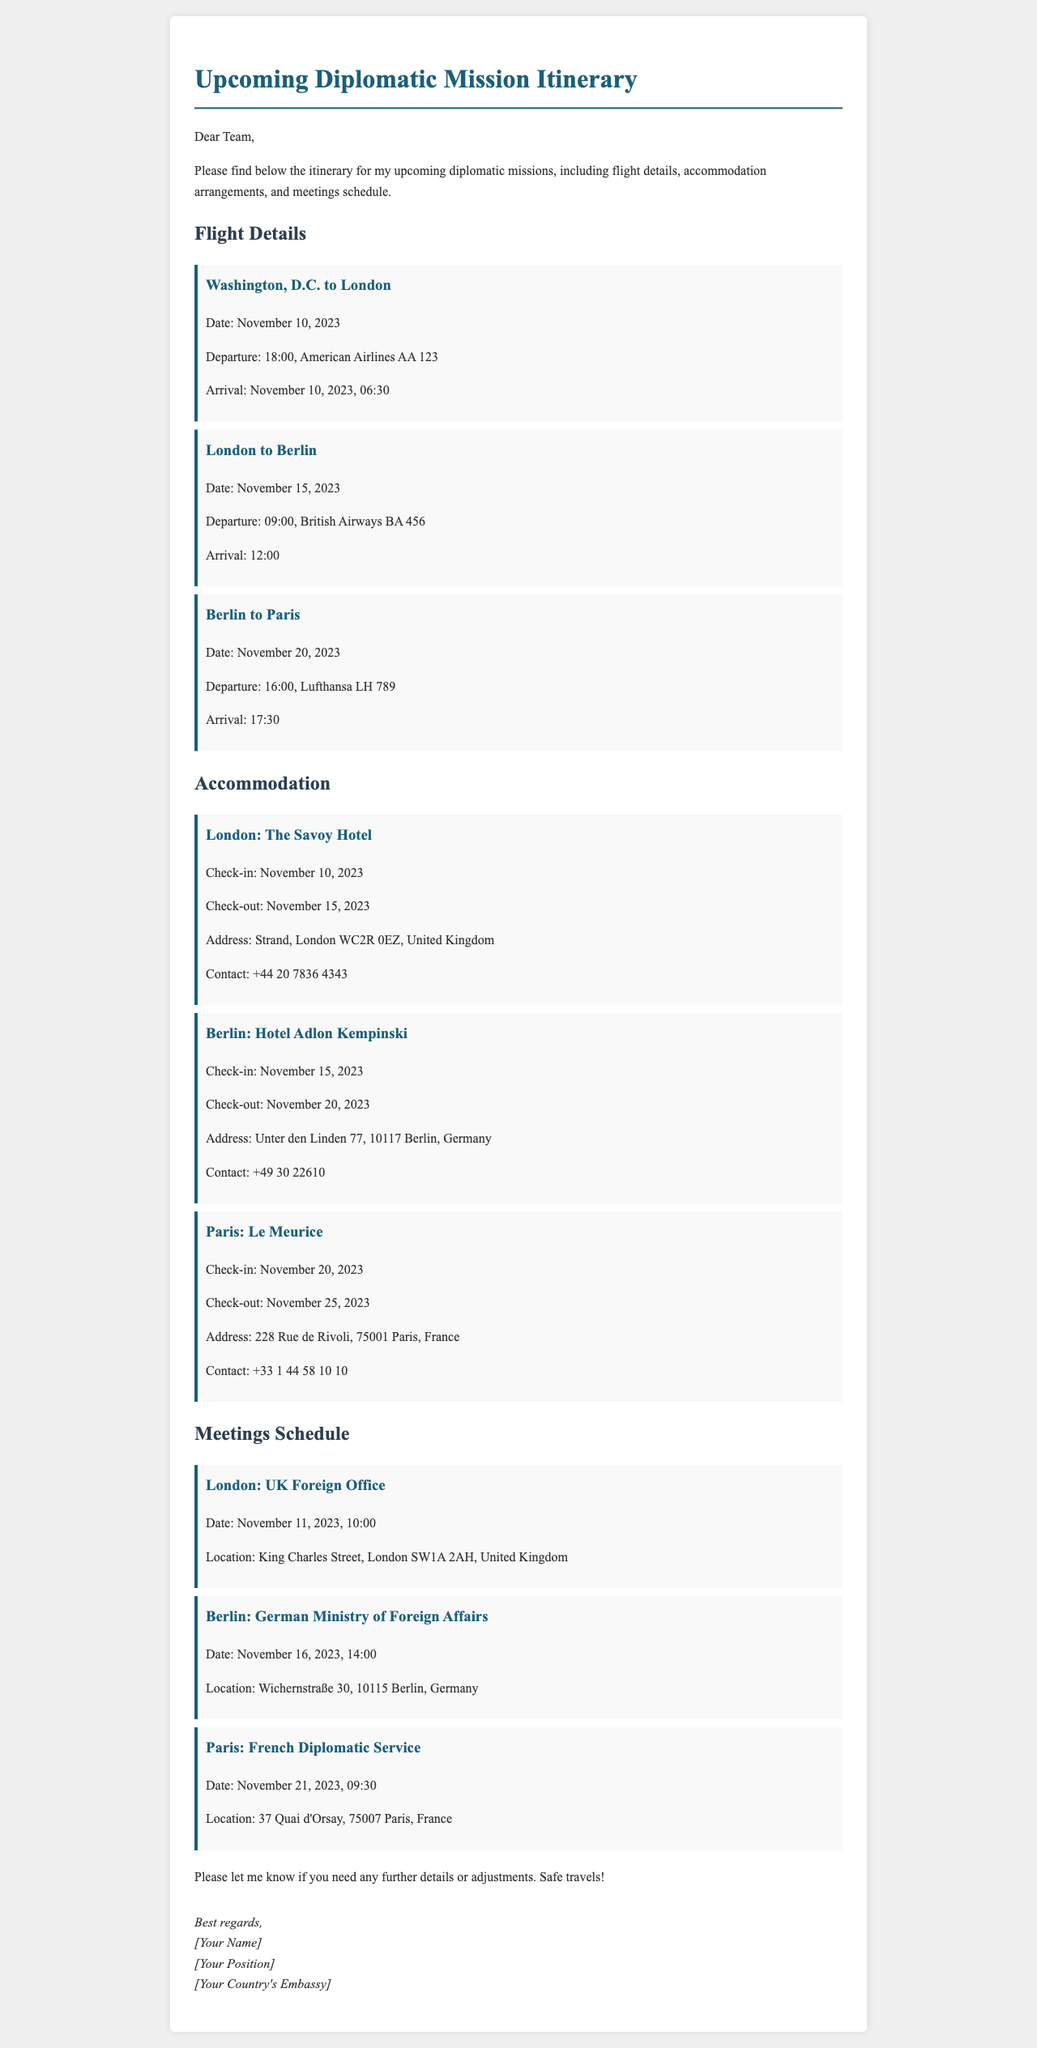What is the departure date for the flight from Washington, D.C. to London? The first flight departing from Washington, D.C. to London is scheduled for November 10, 2023.
Answer: November 10, 2023 What is the contact number for The Savoy Hotel? The document provides a contact number for The Savoy Hotel as +44 20 7836 4343.
Answer: +44 20 7836 4343 Where is the German Ministry of Foreign Affairs located? The address for the German Ministry of Foreign Affairs is Wichernstraße 30, 10115 Berlin, Germany.
Answer: Wichernstraße 30, 10115 Berlin, Germany How many days will the diplomat stay in Paris? The diplomat will check-in at Le Meurice in Paris on November 20, 2023, and check-out on November 25, 2023, totaling five days.
Answer: Five days What time is the meeting at the UK Foreign Office scheduled? The meeting at the UK Foreign Office in London is scheduled for November 11, 2023, at 10:00.
Answer: 10:00 Which airline operates the flight from London to Berlin? The airline operating the flight from London to Berlin is British Airways, with the flight number BA 456.
Answer: British Airways What is the address of Le Meurice? The address of Le Meurice is 228 Rue de Rivoli, 75001 Paris, France.
Answer: 228 Rue de Rivoli, 75001 Paris, France How long will the diplomat be in London total? The diplomat checks into The Savoy Hotel on November 10 and checks out on November 15, making the stay a total of five days.
Answer: Five days 